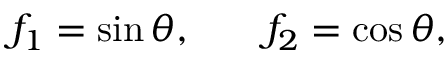Convert formula to latex. <formula><loc_0><loc_0><loc_500><loc_500>\begin{array} { r l r } { f _ { 1 } = \sin { \theta } , } & { f _ { 2 } = \cos { \theta } , } \end{array}</formula> 